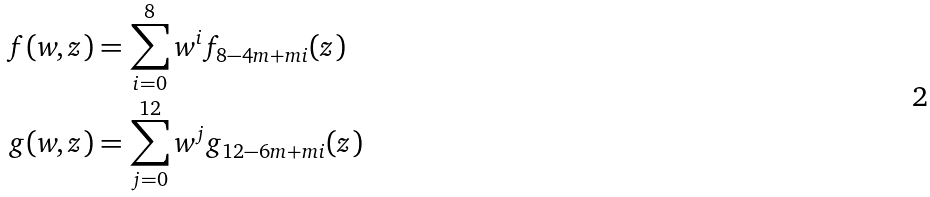<formula> <loc_0><loc_0><loc_500><loc_500>f ( w , z ) & = \sum _ { i = 0 } ^ { 8 } w ^ { i } f _ { 8 - 4 m + m i } ( z ) \\ g ( w , z ) & = \sum _ { j = 0 } ^ { 1 2 } w ^ { j } g _ { 1 2 - 6 m + m i } ( z )</formula> 